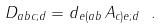<formula> <loc_0><loc_0><loc_500><loc_500>D _ { a b c ; d } = d _ { e ( a b } \, A _ { c ) e ; d } \ .</formula> 